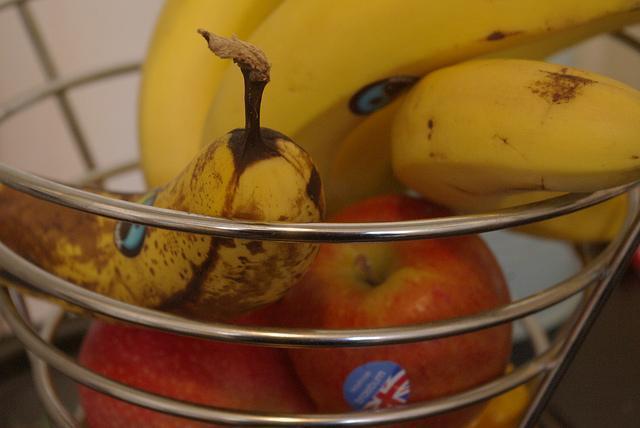How many types of fruits?
Give a very brief answer. 2. How many apples can be seen?
Give a very brief answer. 2. 